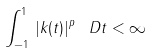Convert formula to latex. <formula><loc_0><loc_0><loc_500><loc_500>\int _ { - 1 } ^ { 1 } \, | k ( t ) | ^ { p } \, \ D t < \infty</formula> 